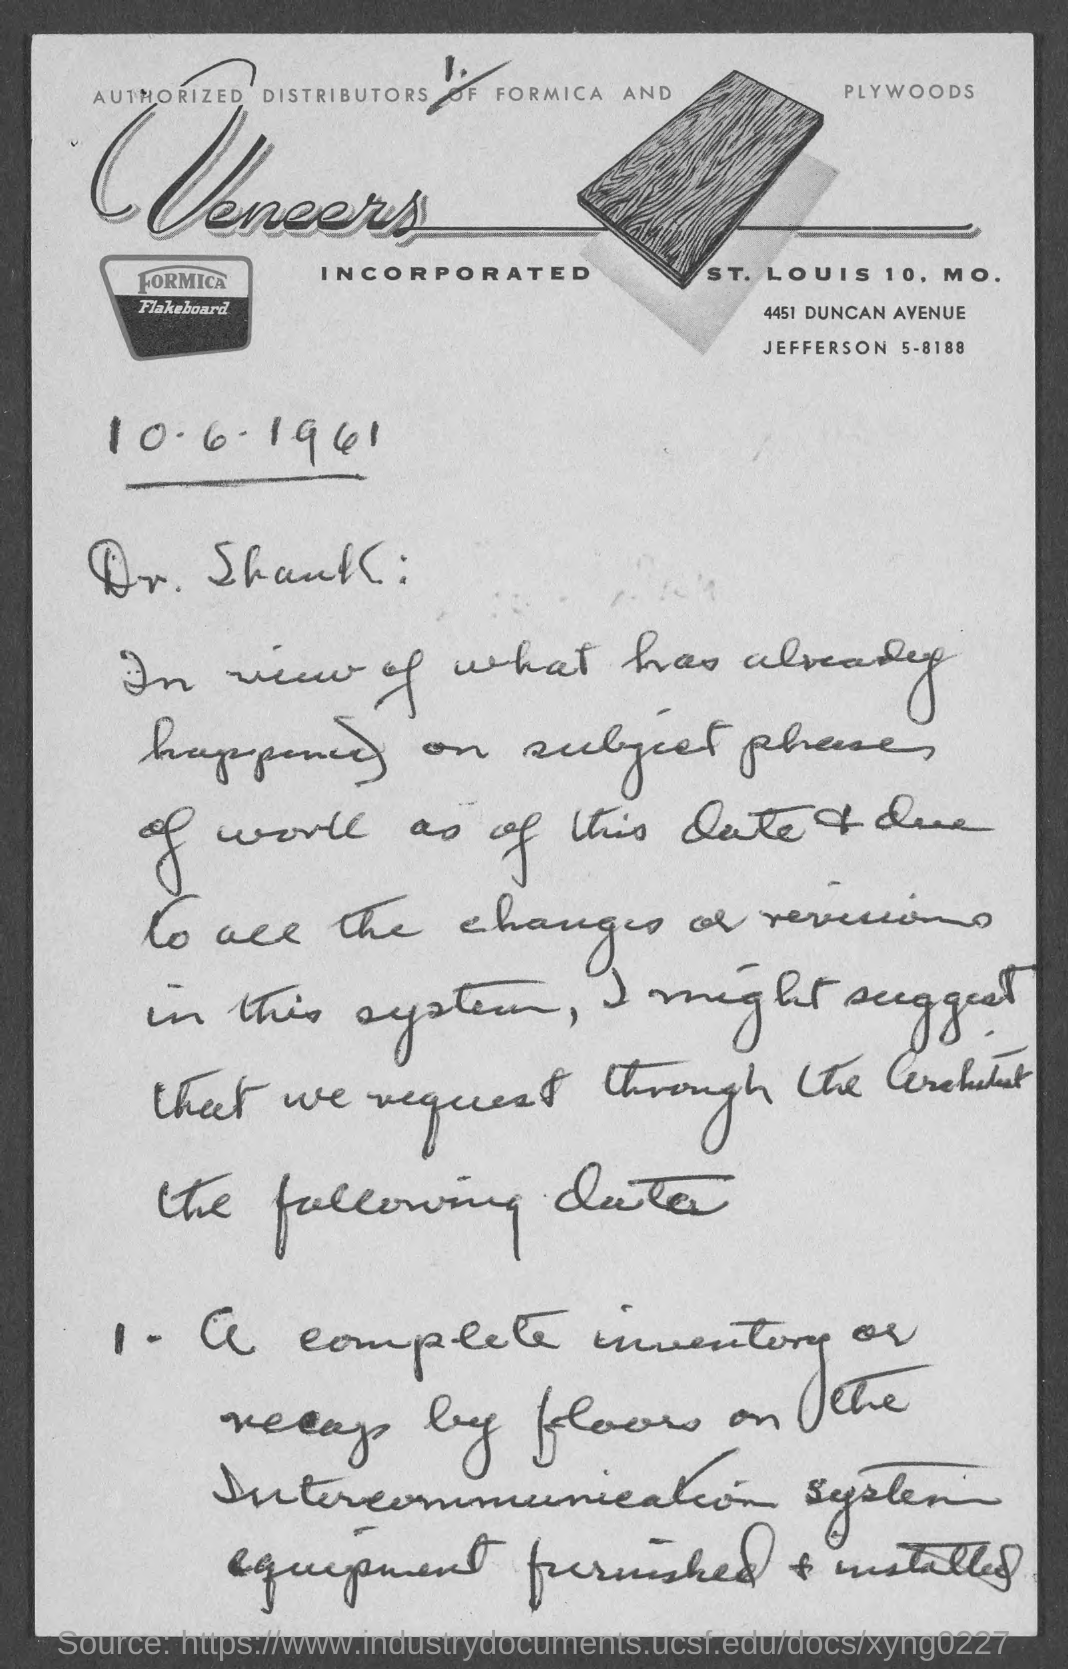List a handful of essential elements in this visual. This document is addressed to Dr. Shank. 